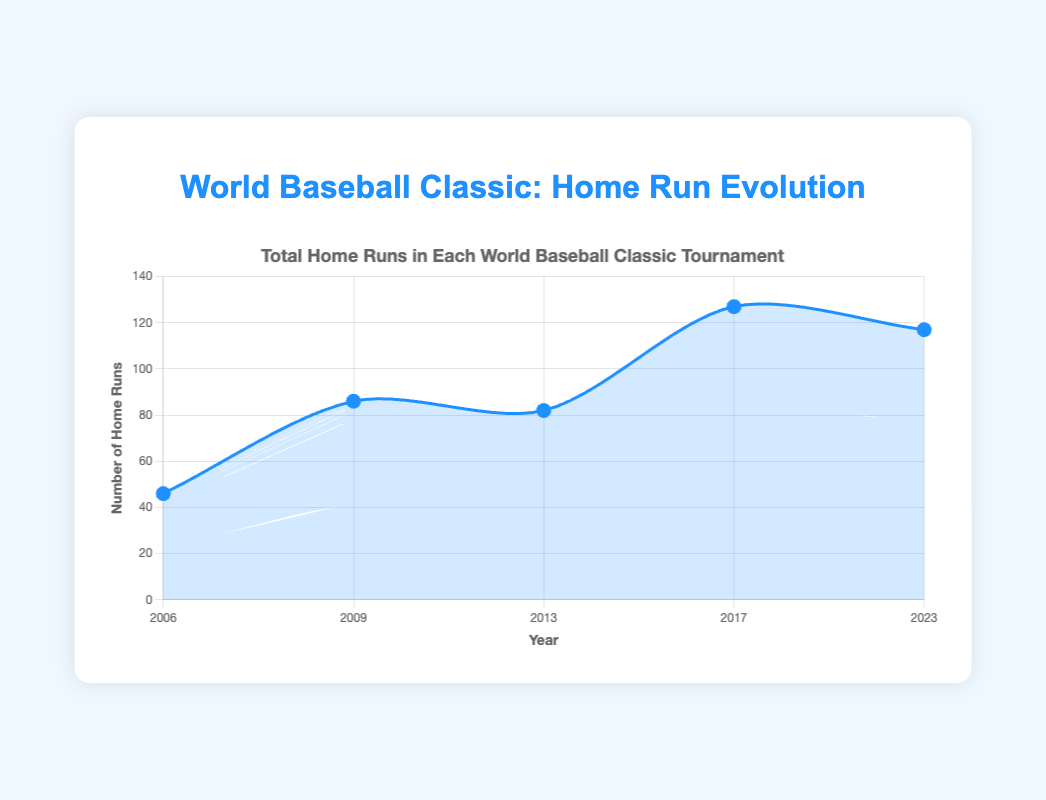How many total home runs were hit in the 2009 and 2013 tournaments combined? First, identify the total home runs for 2009 and 2013 from the figure, which are 86 and 82, respectively. Add these values together: 86 + 82 = 168.
Answer: 168 Which year had the highest number of home runs? Look at the y-axis values for each year and find the highest point on the chart. The highest point corresponds to the year 2017 with 127 home runs.
Answer: 2017 How did the total number of home runs change from 2017 to 2023? Subtract the number of home runs in 2023 from the number in 2017: 127 - 117. This gives a decrease of 10 home runs.
Answer: Decreased by 10 What is the average number of home runs hit per tournament from 2006 to 2023? Sum the total home runs for all years: 46 (2006) + 86 (2009) + 82 (2013) + 127 (2017) + 117 (2023) = 458. There are 5 tournaments, so divide 458 by 5 to get the average: 458 / 5 = 91.6.
Answer: 91.6 Between which two years did the number of home runs increase the most? Calculate the differences in the number of home runs between consecutive years: 
2009-2006: 86 - 46 = 40,
2013-2009: 82 - 86 = -4,
2017-2013: 127 - 82 = 45,
2023-2017: 117 - 127 = -10.
The largest increase is from 2013 to 2017 with an increase of 45 home runs.
Answer: 2013 to 2017 Which two consecutive tournaments had the least change in the number of home runs? Calculate the differences in home runs between consecutive years (as above): 
86 - 46 = 40,
82 - 86 = -4,
127 - 82 = 45,
117 - 127 = -10.
The least change is between 2013 and 2009 with a decrease of 4 home runs.
Answer: 2009 to 2013 What is the median number of home runs hit across the tournaments? List the total home runs for all years in ascending order: 46, 82, 86, 117, 127. The median is the middle value, which is 86.
Answer: 86 In which year did the total home runs exceed 100 for the first time? Trace the line chart and note the first instance where the value exceeds 100. This occurs in the year 2017.
Answer: 2017 